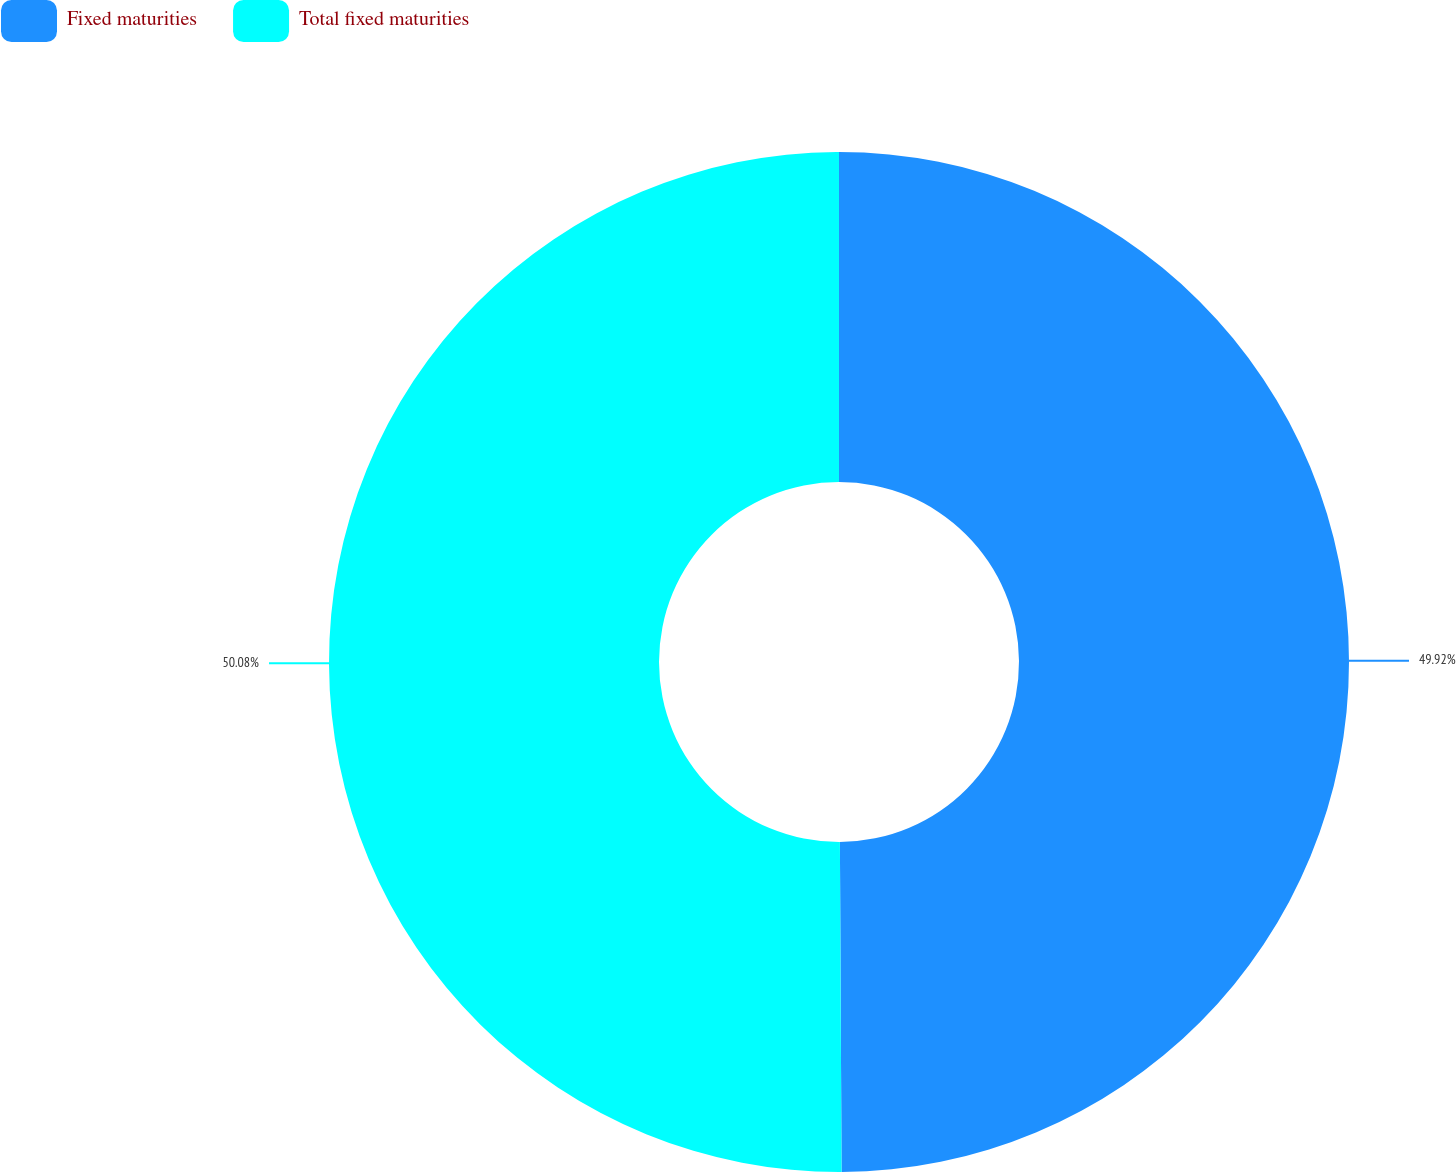<chart> <loc_0><loc_0><loc_500><loc_500><pie_chart><fcel>Fixed maturities<fcel>Total fixed maturities<nl><fcel>49.92%<fcel>50.08%<nl></chart> 